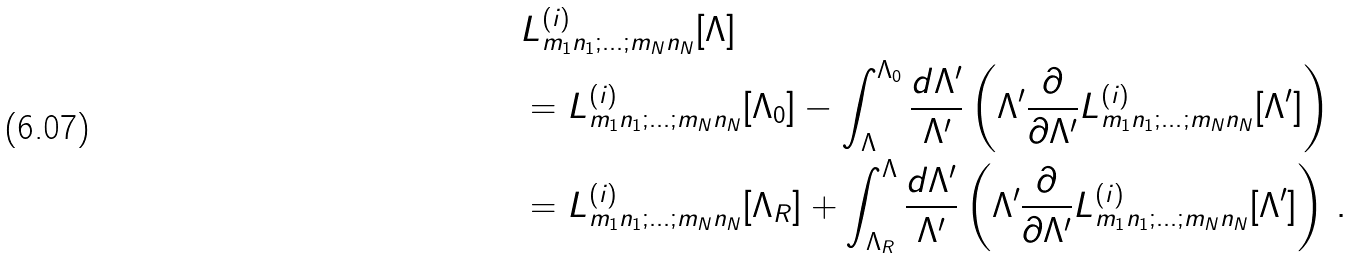<formula> <loc_0><loc_0><loc_500><loc_500>& L _ { m _ { 1 } n _ { 1 } ; \dots ; m _ { N } n _ { N } } ^ { ( i ) } [ \Lambda ] \\ & = L _ { m _ { 1 } n _ { 1 } ; \dots ; m _ { N } n _ { N } } ^ { ( i ) } [ \Lambda _ { 0 } ] - \int _ { \Lambda } ^ { \Lambda _ { 0 } } \frac { d \Lambda ^ { \prime } } { \Lambda ^ { \prime } } \left ( \Lambda ^ { \prime } \frac { \partial } { \partial \Lambda ^ { \prime } } L _ { m _ { 1 } n _ { 1 } ; \dots ; m _ { N } n _ { N } } ^ { ( i ) } [ \Lambda ^ { \prime } ] \right ) \\ & = L _ { m _ { 1 } n _ { 1 } ; \dots ; m _ { N } n _ { N } } ^ { ( i ) } [ \Lambda _ { R } ] + \int _ { \Lambda _ { R } } ^ { \Lambda } \frac { d \Lambda ^ { \prime } } { \Lambda ^ { \prime } } \left ( \Lambda ^ { \prime } \frac { \partial } { \partial \Lambda ^ { \prime } } L _ { m _ { 1 } n _ { 1 } ; \dots ; m _ { N } n _ { N } } ^ { ( i ) } [ \Lambda ^ { \prime } ] \right ) \, .</formula> 